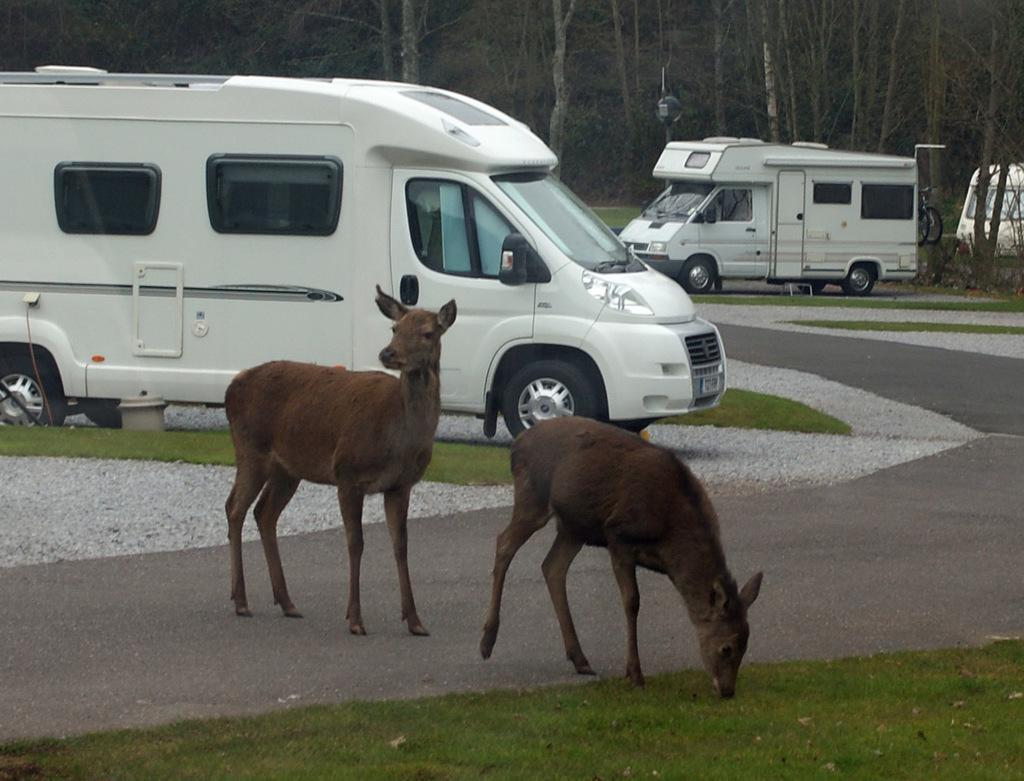What animals can be seen in the foreground of the image? There are deer in the foreground of the image. What type of terrain is visible at the bottom of the image? There is grassland at the bottom side of the image. What can be seen in the background of the image? There are vehicles, stones, grassland, and trees in the background of the image. What type of stem can be seen growing from the word "north" in the image? There is no stem or word "north" present in the image. 